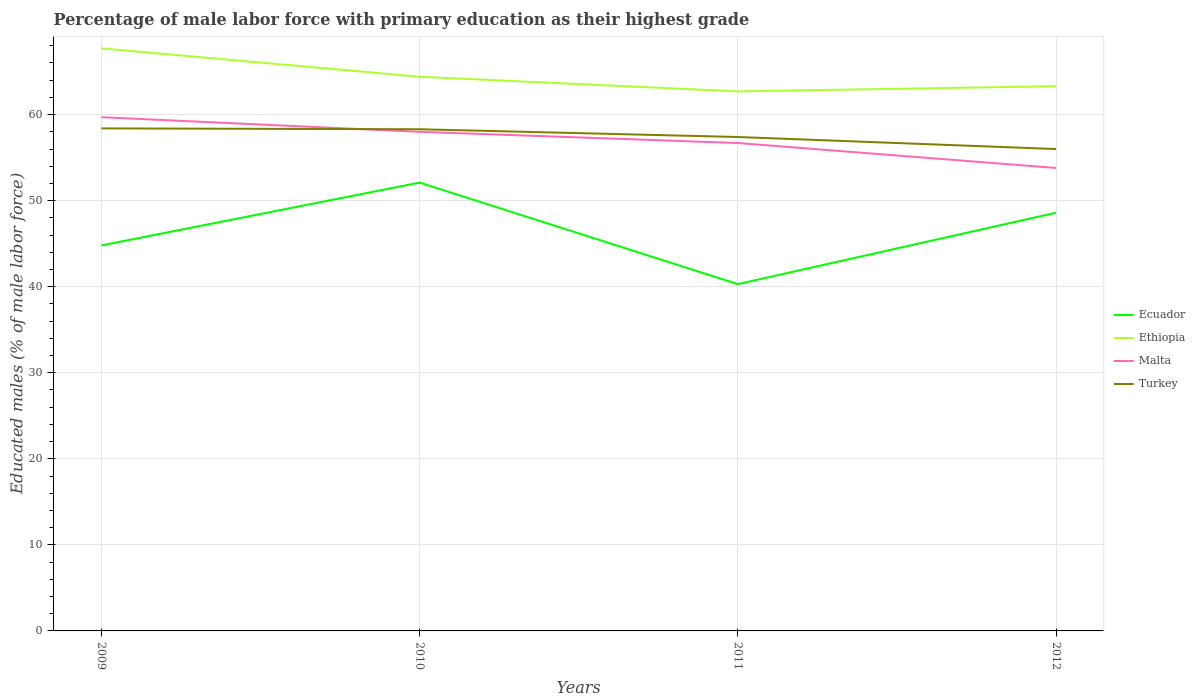How many different coloured lines are there?
Offer a very short reply. 4. Does the line corresponding to Ecuador intersect with the line corresponding to Malta?
Offer a very short reply. No. Across all years, what is the maximum percentage of male labor force with primary education in Ecuador?
Give a very brief answer. 40.3. In which year was the percentage of male labor force with primary education in Turkey maximum?
Keep it short and to the point. 2012. What is the total percentage of male labor force with primary education in Ethiopia in the graph?
Give a very brief answer. 3.3. What is the difference between the highest and the second highest percentage of male labor force with primary education in Ethiopia?
Provide a short and direct response. 5. How many years are there in the graph?
Offer a very short reply. 4. Does the graph contain grids?
Your answer should be compact. Yes. Where does the legend appear in the graph?
Ensure brevity in your answer.  Center right. How many legend labels are there?
Ensure brevity in your answer.  4. How are the legend labels stacked?
Offer a very short reply. Vertical. What is the title of the graph?
Make the answer very short. Percentage of male labor force with primary education as their highest grade. What is the label or title of the Y-axis?
Give a very brief answer. Educated males (% of male labor force). What is the Educated males (% of male labor force) of Ecuador in 2009?
Ensure brevity in your answer.  44.8. What is the Educated males (% of male labor force) in Ethiopia in 2009?
Your response must be concise. 67.7. What is the Educated males (% of male labor force) of Malta in 2009?
Offer a terse response. 59.7. What is the Educated males (% of male labor force) of Turkey in 2009?
Keep it short and to the point. 58.4. What is the Educated males (% of male labor force) of Ecuador in 2010?
Offer a terse response. 52.1. What is the Educated males (% of male labor force) in Ethiopia in 2010?
Offer a terse response. 64.4. What is the Educated males (% of male labor force) in Turkey in 2010?
Your response must be concise. 58.3. What is the Educated males (% of male labor force) of Ecuador in 2011?
Your answer should be compact. 40.3. What is the Educated males (% of male labor force) in Ethiopia in 2011?
Your answer should be compact. 62.7. What is the Educated males (% of male labor force) of Malta in 2011?
Provide a succinct answer. 56.7. What is the Educated males (% of male labor force) in Turkey in 2011?
Offer a terse response. 57.4. What is the Educated males (% of male labor force) of Ecuador in 2012?
Your response must be concise. 48.6. What is the Educated males (% of male labor force) in Ethiopia in 2012?
Provide a short and direct response. 63.3. What is the Educated males (% of male labor force) of Malta in 2012?
Keep it short and to the point. 53.8. Across all years, what is the maximum Educated males (% of male labor force) in Ecuador?
Give a very brief answer. 52.1. Across all years, what is the maximum Educated males (% of male labor force) in Ethiopia?
Offer a very short reply. 67.7. Across all years, what is the maximum Educated males (% of male labor force) of Malta?
Provide a short and direct response. 59.7. Across all years, what is the maximum Educated males (% of male labor force) of Turkey?
Provide a short and direct response. 58.4. Across all years, what is the minimum Educated males (% of male labor force) in Ecuador?
Your response must be concise. 40.3. Across all years, what is the minimum Educated males (% of male labor force) in Ethiopia?
Provide a short and direct response. 62.7. Across all years, what is the minimum Educated males (% of male labor force) of Malta?
Give a very brief answer. 53.8. What is the total Educated males (% of male labor force) in Ecuador in the graph?
Your response must be concise. 185.8. What is the total Educated males (% of male labor force) of Ethiopia in the graph?
Make the answer very short. 258.1. What is the total Educated males (% of male labor force) in Malta in the graph?
Your answer should be compact. 228.2. What is the total Educated males (% of male labor force) in Turkey in the graph?
Make the answer very short. 230.1. What is the difference between the Educated males (% of male labor force) of Ecuador in 2009 and that in 2010?
Give a very brief answer. -7.3. What is the difference between the Educated males (% of male labor force) in Turkey in 2009 and that in 2011?
Make the answer very short. 1. What is the difference between the Educated males (% of male labor force) of Ecuador in 2009 and that in 2012?
Offer a terse response. -3.8. What is the difference between the Educated males (% of male labor force) of Ethiopia in 2009 and that in 2012?
Your answer should be very brief. 4.4. What is the difference between the Educated males (% of male labor force) in Malta in 2009 and that in 2012?
Offer a very short reply. 5.9. What is the difference between the Educated males (% of male labor force) of Ecuador in 2010 and that in 2011?
Your answer should be compact. 11.8. What is the difference between the Educated males (% of male labor force) of Ethiopia in 2010 and that in 2011?
Offer a very short reply. 1.7. What is the difference between the Educated males (% of male labor force) of Malta in 2010 and that in 2011?
Your answer should be compact. 1.3. What is the difference between the Educated males (% of male labor force) in Turkey in 2010 and that in 2011?
Provide a succinct answer. 0.9. What is the difference between the Educated males (% of male labor force) in Ethiopia in 2010 and that in 2012?
Provide a short and direct response. 1.1. What is the difference between the Educated males (% of male labor force) of Malta in 2010 and that in 2012?
Offer a very short reply. 4.2. What is the difference between the Educated males (% of male labor force) in Ethiopia in 2011 and that in 2012?
Offer a very short reply. -0.6. What is the difference between the Educated males (% of male labor force) of Malta in 2011 and that in 2012?
Your response must be concise. 2.9. What is the difference between the Educated males (% of male labor force) in Turkey in 2011 and that in 2012?
Your answer should be very brief. 1.4. What is the difference between the Educated males (% of male labor force) in Ecuador in 2009 and the Educated males (% of male labor force) in Ethiopia in 2010?
Give a very brief answer. -19.6. What is the difference between the Educated males (% of male labor force) in Ecuador in 2009 and the Educated males (% of male labor force) in Turkey in 2010?
Ensure brevity in your answer.  -13.5. What is the difference between the Educated males (% of male labor force) of Ethiopia in 2009 and the Educated males (% of male labor force) of Turkey in 2010?
Provide a succinct answer. 9.4. What is the difference between the Educated males (% of male labor force) in Malta in 2009 and the Educated males (% of male labor force) in Turkey in 2010?
Provide a succinct answer. 1.4. What is the difference between the Educated males (% of male labor force) in Ecuador in 2009 and the Educated males (% of male labor force) in Ethiopia in 2011?
Make the answer very short. -17.9. What is the difference between the Educated males (% of male labor force) in Malta in 2009 and the Educated males (% of male labor force) in Turkey in 2011?
Provide a short and direct response. 2.3. What is the difference between the Educated males (% of male labor force) in Ecuador in 2009 and the Educated males (% of male labor force) in Ethiopia in 2012?
Keep it short and to the point. -18.5. What is the difference between the Educated males (% of male labor force) of Ecuador in 2009 and the Educated males (% of male labor force) of Malta in 2012?
Your answer should be very brief. -9. What is the difference between the Educated males (% of male labor force) in Ecuador in 2009 and the Educated males (% of male labor force) in Turkey in 2012?
Offer a very short reply. -11.2. What is the difference between the Educated males (% of male labor force) in Ethiopia in 2009 and the Educated males (% of male labor force) in Malta in 2012?
Your answer should be compact. 13.9. What is the difference between the Educated males (% of male labor force) in Ethiopia in 2009 and the Educated males (% of male labor force) in Turkey in 2012?
Provide a succinct answer. 11.7. What is the difference between the Educated males (% of male labor force) in Malta in 2009 and the Educated males (% of male labor force) in Turkey in 2012?
Make the answer very short. 3.7. What is the difference between the Educated males (% of male labor force) in Ethiopia in 2010 and the Educated males (% of male labor force) in Turkey in 2011?
Your answer should be compact. 7. What is the difference between the Educated males (% of male labor force) of Malta in 2010 and the Educated males (% of male labor force) of Turkey in 2011?
Keep it short and to the point. 0.6. What is the difference between the Educated males (% of male labor force) of Ecuador in 2010 and the Educated males (% of male labor force) of Ethiopia in 2012?
Provide a succinct answer. -11.2. What is the difference between the Educated males (% of male labor force) of Ecuador in 2010 and the Educated males (% of male labor force) of Turkey in 2012?
Offer a very short reply. -3.9. What is the difference between the Educated males (% of male labor force) of Ecuador in 2011 and the Educated males (% of male labor force) of Malta in 2012?
Make the answer very short. -13.5. What is the difference between the Educated males (% of male labor force) of Ecuador in 2011 and the Educated males (% of male labor force) of Turkey in 2012?
Offer a very short reply. -15.7. What is the difference between the Educated males (% of male labor force) in Ethiopia in 2011 and the Educated males (% of male labor force) in Malta in 2012?
Your answer should be compact. 8.9. What is the average Educated males (% of male labor force) in Ecuador per year?
Offer a very short reply. 46.45. What is the average Educated males (% of male labor force) in Ethiopia per year?
Offer a terse response. 64.53. What is the average Educated males (% of male labor force) of Malta per year?
Ensure brevity in your answer.  57.05. What is the average Educated males (% of male labor force) of Turkey per year?
Provide a short and direct response. 57.52. In the year 2009, what is the difference between the Educated males (% of male labor force) of Ecuador and Educated males (% of male labor force) of Ethiopia?
Keep it short and to the point. -22.9. In the year 2009, what is the difference between the Educated males (% of male labor force) in Ecuador and Educated males (% of male labor force) in Malta?
Your answer should be compact. -14.9. In the year 2009, what is the difference between the Educated males (% of male labor force) of Ecuador and Educated males (% of male labor force) of Turkey?
Your answer should be very brief. -13.6. In the year 2009, what is the difference between the Educated males (% of male labor force) of Ethiopia and Educated males (% of male labor force) of Malta?
Your response must be concise. 8. In the year 2009, what is the difference between the Educated males (% of male labor force) of Ethiopia and Educated males (% of male labor force) of Turkey?
Offer a terse response. 9.3. In the year 2010, what is the difference between the Educated males (% of male labor force) of Ecuador and Educated males (% of male labor force) of Ethiopia?
Offer a very short reply. -12.3. In the year 2010, what is the difference between the Educated males (% of male labor force) in Ethiopia and Educated males (% of male labor force) in Malta?
Offer a very short reply. 6.4. In the year 2010, what is the difference between the Educated males (% of male labor force) of Ethiopia and Educated males (% of male labor force) of Turkey?
Provide a short and direct response. 6.1. In the year 2011, what is the difference between the Educated males (% of male labor force) in Ecuador and Educated males (% of male labor force) in Ethiopia?
Offer a terse response. -22.4. In the year 2011, what is the difference between the Educated males (% of male labor force) of Ecuador and Educated males (% of male labor force) of Malta?
Offer a terse response. -16.4. In the year 2011, what is the difference between the Educated males (% of male labor force) in Ecuador and Educated males (% of male labor force) in Turkey?
Keep it short and to the point. -17.1. In the year 2011, what is the difference between the Educated males (% of male labor force) in Malta and Educated males (% of male labor force) in Turkey?
Your answer should be very brief. -0.7. In the year 2012, what is the difference between the Educated males (% of male labor force) of Ecuador and Educated males (% of male labor force) of Ethiopia?
Make the answer very short. -14.7. In the year 2012, what is the difference between the Educated males (% of male labor force) in Ecuador and Educated males (% of male labor force) in Malta?
Your answer should be compact. -5.2. In the year 2012, what is the difference between the Educated males (% of male labor force) of Ecuador and Educated males (% of male labor force) of Turkey?
Provide a succinct answer. -7.4. In the year 2012, what is the difference between the Educated males (% of male labor force) in Ethiopia and Educated males (% of male labor force) in Malta?
Keep it short and to the point. 9.5. What is the ratio of the Educated males (% of male labor force) of Ecuador in 2009 to that in 2010?
Give a very brief answer. 0.86. What is the ratio of the Educated males (% of male labor force) of Ethiopia in 2009 to that in 2010?
Ensure brevity in your answer.  1.05. What is the ratio of the Educated males (% of male labor force) in Malta in 2009 to that in 2010?
Give a very brief answer. 1.03. What is the ratio of the Educated males (% of male labor force) in Ecuador in 2009 to that in 2011?
Offer a terse response. 1.11. What is the ratio of the Educated males (% of male labor force) in Ethiopia in 2009 to that in 2011?
Make the answer very short. 1.08. What is the ratio of the Educated males (% of male labor force) in Malta in 2009 to that in 2011?
Offer a very short reply. 1.05. What is the ratio of the Educated males (% of male labor force) in Turkey in 2009 to that in 2011?
Keep it short and to the point. 1.02. What is the ratio of the Educated males (% of male labor force) in Ecuador in 2009 to that in 2012?
Ensure brevity in your answer.  0.92. What is the ratio of the Educated males (% of male labor force) of Ethiopia in 2009 to that in 2012?
Ensure brevity in your answer.  1.07. What is the ratio of the Educated males (% of male labor force) of Malta in 2009 to that in 2012?
Give a very brief answer. 1.11. What is the ratio of the Educated males (% of male labor force) of Turkey in 2009 to that in 2012?
Give a very brief answer. 1.04. What is the ratio of the Educated males (% of male labor force) of Ecuador in 2010 to that in 2011?
Keep it short and to the point. 1.29. What is the ratio of the Educated males (% of male labor force) in Ethiopia in 2010 to that in 2011?
Your answer should be very brief. 1.03. What is the ratio of the Educated males (% of male labor force) of Malta in 2010 to that in 2011?
Offer a very short reply. 1.02. What is the ratio of the Educated males (% of male labor force) of Turkey in 2010 to that in 2011?
Give a very brief answer. 1.02. What is the ratio of the Educated males (% of male labor force) of Ecuador in 2010 to that in 2012?
Keep it short and to the point. 1.07. What is the ratio of the Educated males (% of male labor force) of Ethiopia in 2010 to that in 2012?
Provide a short and direct response. 1.02. What is the ratio of the Educated males (% of male labor force) in Malta in 2010 to that in 2012?
Give a very brief answer. 1.08. What is the ratio of the Educated males (% of male labor force) of Turkey in 2010 to that in 2012?
Provide a short and direct response. 1.04. What is the ratio of the Educated males (% of male labor force) in Ecuador in 2011 to that in 2012?
Your answer should be compact. 0.83. What is the ratio of the Educated males (% of male labor force) in Malta in 2011 to that in 2012?
Your response must be concise. 1.05. What is the ratio of the Educated males (% of male labor force) of Turkey in 2011 to that in 2012?
Provide a succinct answer. 1.02. What is the difference between the highest and the second highest Educated males (% of male labor force) of Ecuador?
Provide a succinct answer. 3.5. What is the difference between the highest and the second highest Educated males (% of male labor force) of Ethiopia?
Provide a succinct answer. 3.3. What is the difference between the highest and the second highest Educated males (% of male labor force) of Turkey?
Your answer should be compact. 0.1. What is the difference between the highest and the lowest Educated males (% of male labor force) of Malta?
Make the answer very short. 5.9. 